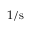Convert formula to latex. <formula><loc_0><loc_0><loc_500><loc_500>1 / s</formula> 